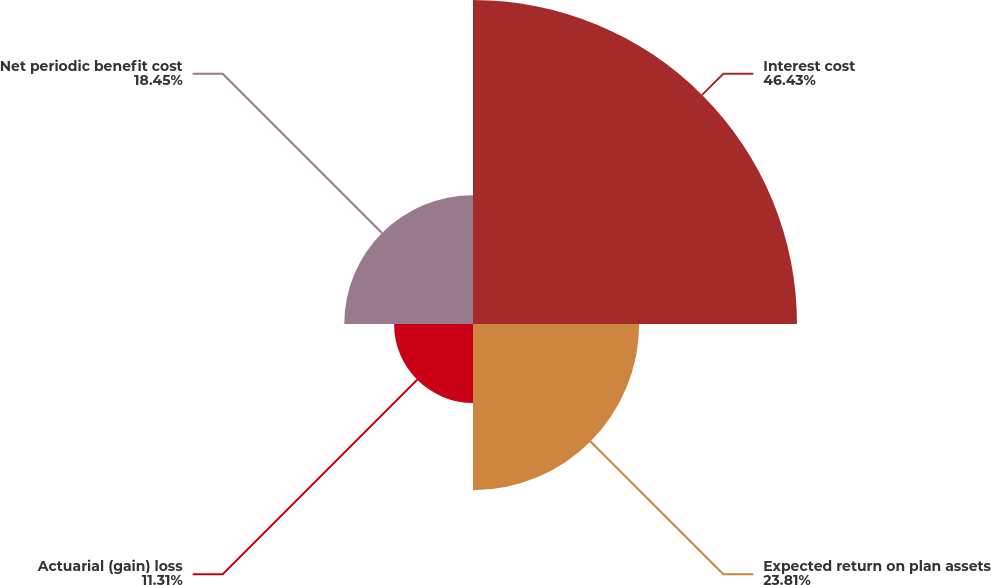Convert chart. <chart><loc_0><loc_0><loc_500><loc_500><pie_chart><fcel>Interest cost<fcel>Expected return on plan assets<fcel>Actuarial (gain) loss<fcel>Net periodic benefit cost<nl><fcel>46.43%<fcel>23.81%<fcel>11.31%<fcel>18.45%<nl></chart> 